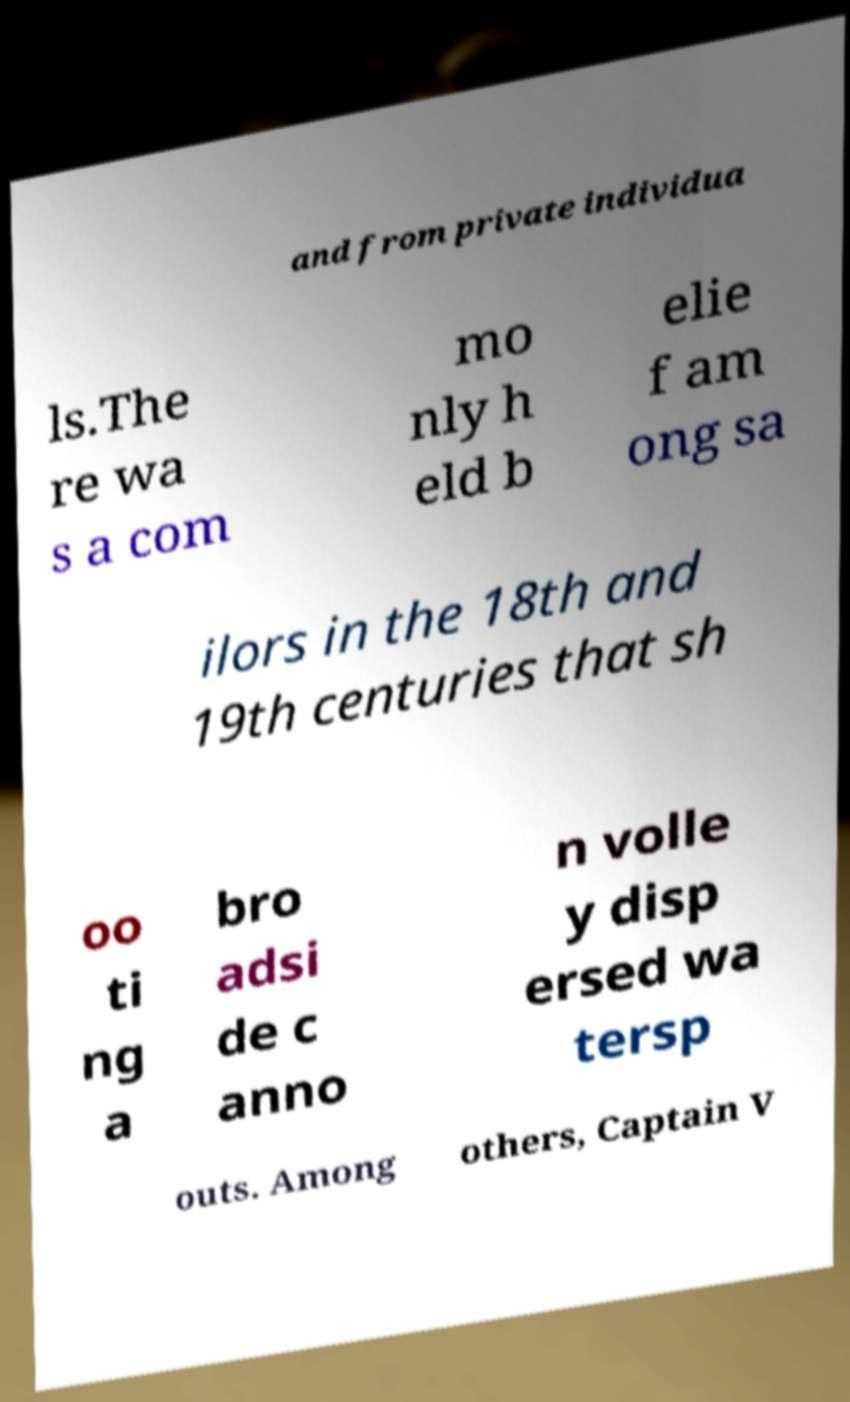Please read and relay the text visible in this image. What does it say? and from private individua ls.The re wa s a com mo nly h eld b elie f am ong sa ilors in the 18th and 19th centuries that sh oo ti ng a bro adsi de c anno n volle y disp ersed wa tersp outs. Among others, Captain V 